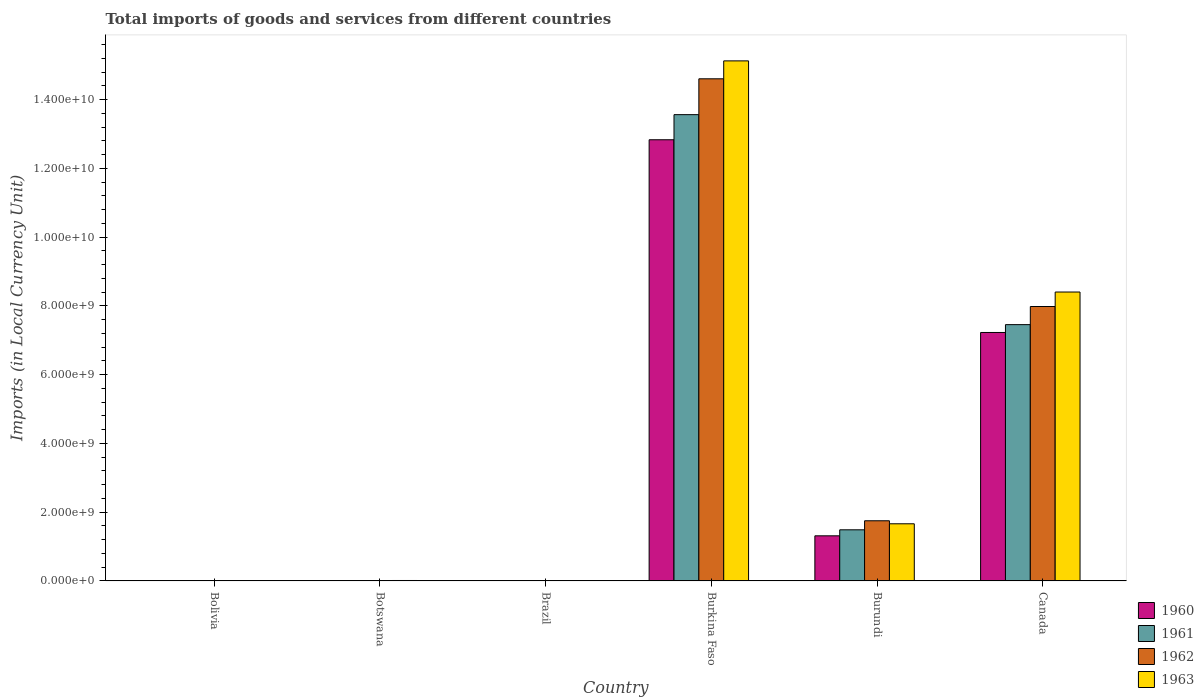How many different coloured bars are there?
Offer a terse response. 4. How many groups of bars are there?
Provide a short and direct response. 6. Are the number of bars on each tick of the X-axis equal?
Keep it short and to the point. Yes. How many bars are there on the 2nd tick from the left?
Offer a very short reply. 4. What is the label of the 6th group of bars from the left?
Provide a succinct answer. Canada. What is the Amount of goods and services imports in 1963 in Burkina Faso?
Make the answer very short. 1.51e+1. Across all countries, what is the maximum Amount of goods and services imports in 1962?
Offer a terse response. 1.46e+1. Across all countries, what is the minimum Amount of goods and services imports in 1960?
Your response must be concise. 7.33493e-5. In which country was the Amount of goods and services imports in 1962 maximum?
Provide a short and direct response. Burkina Faso. In which country was the Amount of goods and services imports in 1961 minimum?
Your answer should be compact. Brazil. What is the total Amount of goods and services imports in 1962 in the graph?
Your response must be concise. 2.44e+1. What is the difference between the Amount of goods and services imports in 1963 in Bolivia and that in Burkina Faso?
Ensure brevity in your answer.  -1.51e+1. What is the difference between the Amount of goods and services imports in 1963 in Burundi and the Amount of goods and services imports in 1960 in Brazil?
Your answer should be very brief. 1.66e+09. What is the average Amount of goods and services imports in 1960 per country?
Make the answer very short. 3.56e+09. What is the difference between the Amount of goods and services imports of/in 1960 and Amount of goods and services imports of/in 1962 in Burkina Faso?
Make the answer very short. -1.77e+09. What is the ratio of the Amount of goods and services imports in 1963 in Bolivia to that in Canada?
Your answer should be compact. 2.141785352670755e-7. Is the Amount of goods and services imports in 1963 in Bolivia less than that in Brazil?
Offer a very short reply. No. What is the difference between the highest and the second highest Amount of goods and services imports in 1961?
Provide a succinct answer. 6.11e+09. What is the difference between the highest and the lowest Amount of goods and services imports in 1963?
Your answer should be very brief. 1.51e+1. Is it the case that in every country, the sum of the Amount of goods and services imports in 1961 and Amount of goods and services imports in 1963 is greater than the sum of Amount of goods and services imports in 1962 and Amount of goods and services imports in 1960?
Provide a short and direct response. No. What does the 1st bar from the left in Burundi represents?
Keep it short and to the point. 1960. Is it the case that in every country, the sum of the Amount of goods and services imports in 1961 and Amount of goods and services imports in 1962 is greater than the Amount of goods and services imports in 1963?
Ensure brevity in your answer.  No. Are all the bars in the graph horizontal?
Give a very brief answer. No. What is the difference between two consecutive major ticks on the Y-axis?
Provide a succinct answer. 2.00e+09. Are the values on the major ticks of Y-axis written in scientific E-notation?
Keep it short and to the point. Yes. Does the graph contain grids?
Offer a terse response. No. Where does the legend appear in the graph?
Your response must be concise. Bottom right. How are the legend labels stacked?
Offer a terse response. Vertical. What is the title of the graph?
Offer a terse response. Total imports of goods and services from different countries. What is the label or title of the Y-axis?
Provide a short and direct response. Imports (in Local Currency Unit). What is the Imports (in Local Currency Unit) in 1960 in Bolivia?
Your answer should be very brief. 1300. What is the Imports (in Local Currency Unit) in 1961 in Bolivia?
Make the answer very short. 1300. What is the Imports (in Local Currency Unit) in 1962 in Bolivia?
Your response must be concise. 1600. What is the Imports (in Local Currency Unit) of 1963 in Bolivia?
Offer a very short reply. 1800. What is the Imports (in Local Currency Unit) of 1960 in Botswana?
Keep it short and to the point. 8.60e+06. What is the Imports (in Local Currency Unit) of 1961 in Botswana?
Your answer should be compact. 1.00e+07. What is the Imports (in Local Currency Unit) in 1962 in Botswana?
Keep it short and to the point. 1.14e+07. What is the Imports (in Local Currency Unit) of 1963 in Botswana?
Make the answer very short. 1.29e+07. What is the Imports (in Local Currency Unit) in 1960 in Brazil?
Your answer should be very brief. 7.33493e-5. What is the Imports (in Local Currency Unit) in 1961 in Brazil?
Provide a short and direct response. 0. What is the Imports (in Local Currency Unit) of 1962 in Brazil?
Your response must be concise. 0. What is the Imports (in Local Currency Unit) in 1963 in Brazil?
Offer a terse response. 0. What is the Imports (in Local Currency Unit) of 1960 in Burkina Faso?
Provide a short and direct response. 1.28e+1. What is the Imports (in Local Currency Unit) in 1961 in Burkina Faso?
Ensure brevity in your answer.  1.36e+1. What is the Imports (in Local Currency Unit) in 1962 in Burkina Faso?
Ensure brevity in your answer.  1.46e+1. What is the Imports (in Local Currency Unit) in 1963 in Burkina Faso?
Keep it short and to the point. 1.51e+1. What is the Imports (in Local Currency Unit) in 1960 in Burundi?
Give a very brief answer. 1.31e+09. What is the Imports (in Local Currency Unit) in 1961 in Burundi?
Ensure brevity in your answer.  1.49e+09. What is the Imports (in Local Currency Unit) in 1962 in Burundi?
Ensure brevity in your answer.  1.75e+09. What is the Imports (in Local Currency Unit) of 1963 in Burundi?
Give a very brief answer. 1.66e+09. What is the Imports (in Local Currency Unit) of 1960 in Canada?
Provide a short and direct response. 7.23e+09. What is the Imports (in Local Currency Unit) in 1961 in Canada?
Make the answer very short. 7.46e+09. What is the Imports (in Local Currency Unit) in 1962 in Canada?
Give a very brief answer. 7.98e+09. What is the Imports (in Local Currency Unit) in 1963 in Canada?
Your answer should be compact. 8.40e+09. Across all countries, what is the maximum Imports (in Local Currency Unit) of 1960?
Your answer should be very brief. 1.28e+1. Across all countries, what is the maximum Imports (in Local Currency Unit) in 1961?
Keep it short and to the point. 1.36e+1. Across all countries, what is the maximum Imports (in Local Currency Unit) of 1962?
Provide a short and direct response. 1.46e+1. Across all countries, what is the maximum Imports (in Local Currency Unit) of 1963?
Give a very brief answer. 1.51e+1. Across all countries, what is the minimum Imports (in Local Currency Unit) in 1960?
Keep it short and to the point. 7.33493e-5. Across all countries, what is the minimum Imports (in Local Currency Unit) of 1961?
Make the answer very short. 0. Across all countries, what is the minimum Imports (in Local Currency Unit) of 1962?
Give a very brief answer. 0. Across all countries, what is the minimum Imports (in Local Currency Unit) in 1963?
Your response must be concise. 0. What is the total Imports (in Local Currency Unit) of 1960 in the graph?
Provide a succinct answer. 2.14e+1. What is the total Imports (in Local Currency Unit) of 1961 in the graph?
Offer a very short reply. 2.25e+1. What is the total Imports (in Local Currency Unit) in 1962 in the graph?
Provide a succinct answer. 2.44e+1. What is the total Imports (in Local Currency Unit) in 1963 in the graph?
Your answer should be very brief. 2.52e+1. What is the difference between the Imports (in Local Currency Unit) of 1960 in Bolivia and that in Botswana?
Keep it short and to the point. -8.60e+06. What is the difference between the Imports (in Local Currency Unit) of 1961 in Bolivia and that in Botswana?
Ensure brevity in your answer.  -1.00e+07. What is the difference between the Imports (in Local Currency Unit) in 1962 in Bolivia and that in Botswana?
Offer a terse response. -1.14e+07. What is the difference between the Imports (in Local Currency Unit) of 1963 in Bolivia and that in Botswana?
Provide a succinct answer. -1.29e+07. What is the difference between the Imports (in Local Currency Unit) of 1960 in Bolivia and that in Brazil?
Ensure brevity in your answer.  1300. What is the difference between the Imports (in Local Currency Unit) of 1961 in Bolivia and that in Brazil?
Provide a short and direct response. 1300. What is the difference between the Imports (in Local Currency Unit) of 1962 in Bolivia and that in Brazil?
Provide a succinct answer. 1600. What is the difference between the Imports (in Local Currency Unit) of 1963 in Bolivia and that in Brazil?
Provide a short and direct response. 1800. What is the difference between the Imports (in Local Currency Unit) in 1960 in Bolivia and that in Burkina Faso?
Make the answer very short. -1.28e+1. What is the difference between the Imports (in Local Currency Unit) in 1961 in Bolivia and that in Burkina Faso?
Provide a succinct answer. -1.36e+1. What is the difference between the Imports (in Local Currency Unit) of 1962 in Bolivia and that in Burkina Faso?
Your answer should be very brief. -1.46e+1. What is the difference between the Imports (in Local Currency Unit) of 1963 in Bolivia and that in Burkina Faso?
Provide a succinct answer. -1.51e+1. What is the difference between the Imports (in Local Currency Unit) in 1960 in Bolivia and that in Burundi?
Keep it short and to the point. -1.31e+09. What is the difference between the Imports (in Local Currency Unit) of 1961 in Bolivia and that in Burundi?
Your answer should be compact. -1.49e+09. What is the difference between the Imports (in Local Currency Unit) of 1962 in Bolivia and that in Burundi?
Your answer should be very brief. -1.75e+09. What is the difference between the Imports (in Local Currency Unit) in 1963 in Bolivia and that in Burundi?
Your answer should be compact. -1.66e+09. What is the difference between the Imports (in Local Currency Unit) in 1960 in Bolivia and that in Canada?
Keep it short and to the point. -7.23e+09. What is the difference between the Imports (in Local Currency Unit) of 1961 in Bolivia and that in Canada?
Give a very brief answer. -7.46e+09. What is the difference between the Imports (in Local Currency Unit) in 1962 in Bolivia and that in Canada?
Offer a terse response. -7.98e+09. What is the difference between the Imports (in Local Currency Unit) of 1963 in Bolivia and that in Canada?
Offer a terse response. -8.40e+09. What is the difference between the Imports (in Local Currency Unit) in 1960 in Botswana and that in Brazil?
Give a very brief answer. 8.60e+06. What is the difference between the Imports (in Local Currency Unit) in 1961 in Botswana and that in Brazil?
Keep it short and to the point. 1.00e+07. What is the difference between the Imports (in Local Currency Unit) of 1962 in Botswana and that in Brazil?
Make the answer very short. 1.14e+07. What is the difference between the Imports (in Local Currency Unit) of 1963 in Botswana and that in Brazil?
Give a very brief answer. 1.29e+07. What is the difference between the Imports (in Local Currency Unit) of 1960 in Botswana and that in Burkina Faso?
Give a very brief answer. -1.28e+1. What is the difference between the Imports (in Local Currency Unit) of 1961 in Botswana and that in Burkina Faso?
Your answer should be compact. -1.36e+1. What is the difference between the Imports (in Local Currency Unit) of 1962 in Botswana and that in Burkina Faso?
Your response must be concise. -1.46e+1. What is the difference between the Imports (in Local Currency Unit) of 1963 in Botswana and that in Burkina Faso?
Offer a terse response. -1.51e+1. What is the difference between the Imports (in Local Currency Unit) of 1960 in Botswana and that in Burundi?
Give a very brief answer. -1.30e+09. What is the difference between the Imports (in Local Currency Unit) of 1961 in Botswana and that in Burundi?
Provide a succinct answer. -1.48e+09. What is the difference between the Imports (in Local Currency Unit) in 1962 in Botswana and that in Burundi?
Ensure brevity in your answer.  -1.74e+09. What is the difference between the Imports (in Local Currency Unit) of 1963 in Botswana and that in Burundi?
Make the answer very short. -1.65e+09. What is the difference between the Imports (in Local Currency Unit) in 1960 in Botswana and that in Canada?
Provide a succinct answer. -7.22e+09. What is the difference between the Imports (in Local Currency Unit) of 1961 in Botswana and that in Canada?
Your answer should be very brief. -7.45e+09. What is the difference between the Imports (in Local Currency Unit) in 1962 in Botswana and that in Canada?
Ensure brevity in your answer.  -7.97e+09. What is the difference between the Imports (in Local Currency Unit) in 1963 in Botswana and that in Canada?
Your response must be concise. -8.39e+09. What is the difference between the Imports (in Local Currency Unit) in 1960 in Brazil and that in Burkina Faso?
Your answer should be compact. -1.28e+1. What is the difference between the Imports (in Local Currency Unit) in 1961 in Brazil and that in Burkina Faso?
Provide a short and direct response. -1.36e+1. What is the difference between the Imports (in Local Currency Unit) in 1962 in Brazil and that in Burkina Faso?
Your response must be concise. -1.46e+1. What is the difference between the Imports (in Local Currency Unit) of 1963 in Brazil and that in Burkina Faso?
Ensure brevity in your answer.  -1.51e+1. What is the difference between the Imports (in Local Currency Unit) of 1960 in Brazil and that in Burundi?
Your response must be concise. -1.31e+09. What is the difference between the Imports (in Local Currency Unit) of 1961 in Brazil and that in Burundi?
Your answer should be compact. -1.49e+09. What is the difference between the Imports (in Local Currency Unit) in 1962 in Brazil and that in Burundi?
Give a very brief answer. -1.75e+09. What is the difference between the Imports (in Local Currency Unit) in 1963 in Brazil and that in Burundi?
Provide a succinct answer. -1.66e+09. What is the difference between the Imports (in Local Currency Unit) of 1960 in Brazil and that in Canada?
Your answer should be very brief. -7.23e+09. What is the difference between the Imports (in Local Currency Unit) of 1961 in Brazil and that in Canada?
Ensure brevity in your answer.  -7.46e+09. What is the difference between the Imports (in Local Currency Unit) in 1962 in Brazil and that in Canada?
Make the answer very short. -7.98e+09. What is the difference between the Imports (in Local Currency Unit) of 1963 in Brazil and that in Canada?
Provide a short and direct response. -8.40e+09. What is the difference between the Imports (in Local Currency Unit) in 1960 in Burkina Faso and that in Burundi?
Your answer should be compact. 1.15e+1. What is the difference between the Imports (in Local Currency Unit) in 1961 in Burkina Faso and that in Burundi?
Your answer should be compact. 1.21e+1. What is the difference between the Imports (in Local Currency Unit) of 1962 in Burkina Faso and that in Burundi?
Offer a very short reply. 1.29e+1. What is the difference between the Imports (in Local Currency Unit) in 1963 in Burkina Faso and that in Burundi?
Your response must be concise. 1.35e+1. What is the difference between the Imports (in Local Currency Unit) of 1960 in Burkina Faso and that in Canada?
Keep it short and to the point. 5.61e+09. What is the difference between the Imports (in Local Currency Unit) in 1961 in Burkina Faso and that in Canada?
Your response must be concise. 6.11e+09. What is the difference between the Imports (in Local Currency Unit) of 1962 in Burkina Faso and that in Canada?
Keep it short and to the point. 6.62e+09. What is the difference between the Imports (in Local Currency Unit) of 1963 in Burkina Faso and that in Canada?
Make the answer very short. 6.72e+09. What is the difference between the Imports (in Local Currency Unit) in 1960 in Burundi and that in Canada?
Offer a terse response. -5.91e+09. What is the difference between the Imports (in Local Currency Unit) of 1961 in Burundi and that in Canada?
Make the answer very short. -5.97e+09. What is the difference between the Imports (in Local Currency Unit) of 1962 in Burundi and that in Canada?
Keep it short and to the point. -6.23e+09. What is the difference between the Imports (in Local Currency Unit) in 1963 in Burundi and that in Canada?
Offer a terse response. -6.74e+09. What is the difference between the Imports (in Local Currency Unit) of 1960 in Bolivia and the Imports (in Local Currency Unit) of 1961 in Botswana?
Offer a very short reply. -1.00e+07. What is the difference between the Imports (in Local Currency Unit) in 1960 in Bolivia and the Imports (in Local Currency Unit) in 1962 in Botswana?
Give a very brief answer. -1.14e+07. What is the difference between the Imports (in Local Currency Unit) of 1960 in Bolivia and the Imports (in Local Currency Unit) of 1963 in Botswana?
Offer a very short reply. -1.29e+07. What is the difference between the Imports (in Local Currency Unit) of 1961 in Bolivia and the Imports (in Local Currency Unit) of 1962 in Botswana?
Your answer should be compact. -1.14e+07. What is the difference between the Imports (in Local Currency Unit) in 1961 in Bolivia and the Imports (in Local Currency Unit) in 1963 in Botswana?
Offer a very short reply. -1.29e+07. What is the difference between the Imports (in Local Currency Unit) of 1962 in Bolivia and the Imports (in Local Currency Unit) of 1963 in Botswana?
Provide a short and direct response. -1.29e+07. What is the difference between the Imports (in Local Currency Unit) in 1960 in Bolivia and the Imports (in Local Currency Unit) in 1961 in Brazil?
Offer a terse response. 1300. What is the difference between the Imports (in Local Currency Unit) in 1960 in Bolivia and the Imports (in Local Currency Unit) in 1962 in Brazil?
Give a very brief answer. 1300. What is the difference between the Imports (in Local Currency Unit) of 1960 in Bolivia and the Imports (in Local Currency Unit) of 1963 in Brazil?
Provide a succinct answer. 1300. What is the difference between the Imports (in Local Currency Unit) of 1961 in Bolivia and the Imports (in Local Currency Unit) of 1962 in Brazil?
Give a very brief answer. 1300. What is the difference between the Imports (in Local Currency Unit) of 1961 in Bolivia and the Imports (in Local Currency Unit) of 1963 in Brazil?
Offer a terse response. 1300. What is the difference between the Imports (in Local Currency Unit) of 1962 in Bolivia and the Imports (in Local Currency Unit) of 1963 in Brazil?
Your answer should be very brief. 1600. What is the difference between the Imports (in Local Currency Unit) of 1960 in Bolivia and the Imports (in Local Currency Unit) of 1961 in Burkina Faso?
Keep it short and to the point. -1.36e+1. What is the difference between the Imports (in Local Currency Unit) in 1960 in Bolivia and the Imports (in Local Currency Unit) in 1962 in Burkina Faso?
Your answer should be compact. -1.46e+1. What is the difference between the Imports (in Local Currency Unit) of 1960 in Bolivia and the Imports (in Local Currency Unit) of 1963 in Burkina Faso?
Offer a terse response. -1.51e+1. What is the difference between the Imports (in Local Currency Unit) of 1961 in Bolivia and the Imports (in Local Currency Unit) of 1962 in Burkina Faso?
Your answer should be very brief. -1.46e+1. What is the difference between the Imports (in Local Currency Unit) of 1961 in Bolivia and the Imports (in Local Currency Unit) of 1963 in Burkina Faso?
Make the answer very short. -1.51e+1. What is the difference between the Imports (in Local Currency Unit) in 1962 in Bolivia and the Imports (in Local Currency Unit) in 1963 in Burkina Faso?
Ensure brevity in your answer.  -1.51e+1. What is the difference between the Imports (in Local Currency Unit) of 1960 in Bolivia and the Imports (in Local Currency Unit) of 1961 in Burundi?
Ensure brevity in your answer.  -1.49e+09. What is the difference between the Imports (in Local Currency Unit) in 1960 in Bolivia and the Imports (in Local Currency Unit) in 1962 in Burundi?
Your answer should be compact. -1.75e+09. What is the difference between the Imports (in Local Currency Unit) in 1960 in Bolivia and the Imports (in Local Currency Unit) in 1963 in Burundi?
Your answer should be compact. -1.66e+09. What is the difference between the Imports (in Local Currency Unit) of 1961 in Bolivia and the Imports (in Local Currency Unit) of 1962 in Burundi?
Ensure brevity in your answer.  -1.75e+09. What is the difference between the Imports (in Local Currency Unit) in 1961 in Bolivia and the Imports (in Local Currency Unit) in 1963 in Burundi?
Give a very brief answer. -1.66e+09. What is the difference between the Imports (in Local Currency Unit) of 1962 in Bolivia and the Imports (in Local Currency Unit) of 1963 in Burundi?
Provide a short and direct response. -1.66e+09. What is the difference between the Imports (in Local Currency Unit) of 1960 in Bolivia and the Imports (in Local Currency Unit) of 1961 in Canada?
Keep it short and to the point. -7.46e+09. What is the difference between the Imports (in Local Currency Unit) of 1960 in Bolivia and the Imports (in Local Currency Unit) of 1962 in Canada?
Ensure brevity in your answer.  -7.98e+09. What is the difference between the Imports (in Local Currency Unit) in 1960 in Bolivia and the Imports (in Local Currency Unit) in 1963 in Canada?
Your answer should be compact. -8.40e+09. What is the difference between the Imports (in Local Currency Unit) of 1961 in Bolivia and the Imports (in Local Currency Unit) of 1962 in Canada?
Provide a short and direct response. -7.98e+09. What is the difference between the Imports (in Local Currency Unit) in 1961 in Bolivia and the Imports (in Local Currency Unit) in 1963 in Canada?
Your answer should be very brief. -8.40e+09. What is the difference between the Imports (in Local Currency Unit) of 1962 in Bolivia and the Imports (in Local Currency Unit) of 1963 in Canada?
Offer a terse response. -8.40e+09. What is the difference between the Imports (in Local Currency Unit) in 1960 in Botswana and the Imports (in Local Currency Unit) in 1961 in Brazil?
Make the answer very short. 8.60e+06. What is the difference between the Imports (in Local Currency Unit) of 1960 in Botswana and the Imports (in Local Currency Unit) of 1962 in Brazil?
Offer a very short reply. 8.60e+06. What is the difference between the Imports (in Local Currency Unit) of 1960 in Botswana and the Imports (in Local Currency Unit) of 1963 in Brazil?
Keep it short and to the point. 8.60e+06. What is the difference between the Imports (in Local Currency Unit) of 1961 in Botswana and the Imports (in Local Currency Unit) of 1962 in Brazil?
Offer a terse response. 1.00e+07. What is the difference between the Imports (in Local Currency Unit) in 1961 in Botswana and the Imports (in Local Currency Unit) in 1963 in Brazil?
Make the answer very short. 1.00e+07. What is the difference between the Imports (in Local Currency Unit) of 1962 in Botswana and the Imports (in Local Currency Unit) of 1963 in Brazil?
Ensure brevity in your answer.  1.14e+07. What is the difference between the Imports (in Local Currency Unit) of 1960 in Botswana and the Imports (in Local Currency Unit) of 1961 in Burkina Faso?
Provide a succinct answer. -1.36e+1. What is the difference between the Imports (in Local Currency Unit) in 1960 in Botswana and the Imports (in Local Currency Unit) in 1962 in Burkina Faso?
Your answer should be compact. -1.46e+1. What is the difference between the Imports (in Local Currency Unit) in 1960 in Botswana and the Imports (in Local Currency Unit) in 1963 in Burkina Faso?
Offer a terse response. -1.51e+1. What is the difference between the Imports (in Local Currency Unit) in 1961 in Botswana and the Imports (in Local Currency Unit) in 1962 in Burkina Faso?
Your answer should be compact. -1.46e+1. What is the difference between the Imports (in Local Currency Unit) in 1961 in Botswana and the Imports (in Local Currency Unit) in 1963 in Burkina Faso?
Give a very brief answer. -1.51e+1. What is the difference between the Imports (in Local Currency Unit) of 1962 in Botswana and the Imports (in Local Currency Unit) of 1963 in Burkina Faso?
Offer a very short reply. -1.51e+1. What is the difference between the Imports (in Local Currency Unit) in 1960 in Botswana and the Imports (in Local Currency Unit) in 1961 in Burundi?
Offer a very short reply. -1.48e+09. What is the difference between the Imports (in Local Currency Unit) of 1960 in Botswana and the Imports (in Local Currency Unit) of 1962 in Burundi?
Offer a very short reply. -1.74e+09. What is the difference between the Imports (in Local Currency Unit) in 1960 in Botswana and the Imports (in Local Currency Unit) in 1963 in Burundi?
Provide a succinct answer. -1.65e+09. What is the difference between the Imports (in Local Currency Unit) in 1961 in Botswana and the Imports (in Local Currency Unit) in 1962 in Burundi?
Offer a terse response. -1.74e+09. What is the difference between the Imports (in Local Currency Unit) of 1961 in Botswana and the Imports (in Local Currency Unit) of 1963 in Burundi?
Keep it short and to the point. -1.65e+09. What is the difference between the Imports (in Local Currency Unit) in 1962 in Botswana and the Imports (in Local Currency Unit) in 1963 in Burundi?
Provide a short and direct response. -1.65e+09. What is the difference between the Imports (in Local Currency Unit) of 1960 in Botswana and the Imports (in Local Currency Unit) of 1961 in Canada?
Keep it short and to the point. -7.45e+09. What is the difference between the Imports (in Local Currency Unit) of 1960 in Botswana and the Imports (in Local Currency Unit) of 1962 in Canada?
Your answer should be very brief. -7.97e+09. What is the difference between the Imports (in Local Currency Unit) in 1960 in Botswana and the Imports (in Local Currency Unit) in 1963 in Canada?
Offer a very short reply. -8.40e+09. What is the difference between the Imports (in Local Currency Unit) in 1961 in Botswana and the Imports (in Local Currency Unit) in 1962 in Canada?
Ensure brevity in your answer.  -7.97e+09. What is the difference between the Imports (in Local Currency Unit) in 1961 in Botswana and the Imports (in Local Currency Unit) in 1963 in Canada?
Offer a terse response. -8.39e+09. What is the difference between the Imports (in Local Currency Unit) of 1962 in Botswana and the Imports (in Local Currency Unit) of 1963 in Canada?
Your response must be concise. -8.39e+09. What is the difference between the Imports (in Local Currency Unit) of 1960 in Brazil and the Imports (in Local Currency Unit) of 1961 in Burkina Faso?
Your response must be concise. -1.36e+1. What is the difference between the Imports (in Local Currency Unit) of 1960 in Brazil and the Imports (in Local Currency Unit) of 1962 in Burkina Faso?
Offer a terse response. -1.46e+1. What is the difference between the Imports (in Local Currency Unit) of 1960 in Brazil and the Imports (in Local Currency Unit) of 1963 in Burkina Faso?
Your answer should be compact. -1.51e+1. What is the difference between the Imports (in Local Currency Unit) in 1961 in Brazil and the Imports (in Local Currency Unit) in 1962 in Burkina Faso?
Provide a succinct answer. -1.46e+1. What is the difference between the Imports (in Local Currency Unit) of 1961 in Brazil and the Imports (in Local Currency Unit) of 1963 in Burkina Faso?
Your response must be concise. -1.51e+1. What is the difference between the Imports (in Local Currency Unit) in 1962 in Brazil and the Imports (in Local Currency Unit) in 1963 in Burkina Faso?
Offer a terse response. -1.51e+1. What is the difference between the Imports (in Local Currency Unit) of 1960 in Brazil and the Imports (in Local Currency Unit) of 1961 in Burundi?
Your answer should be very brief. -1.49e+09. What is the difference between the Imports (in Local Currency Unit) in 1960 in Brazil and the Imports (in Local Currency Unit) in 1962 in Burundi?
Make the answer very short. -1.75e+09. What is the difference between the Imports (in Local Currency Unit) of 1960 in Brazil and the Imports (in Local Currency Unit) of 1963 in Burundi?
Make the answer very short. -1.66e+09. What is the difference between the Imports (in Local Currency Unit) in 1961 in Brazil and the Imports (in Local Currency Unit) in 1962 in Burundi?
Give a very brief answer. -1.75e+09. What is the difference between the Imports (in Local Currency Unit) of 1961 in Brazil and the Imports (in Local Currency Unit) of 1963 in Burundi?
Your answer should be very brief. -1.66e+09. What is the difference between the Imports (in Local Currency Unit) of 1962 in Brazil and the Imports (in Local Currency Unit) of 1963 in Burundi?
Make the answer very short. -1.66e+09. What is the difference between the Imports (in Local Currency Unit) of 1960 in Brazil and the Imports (in Local Currency Unit) of 1961 in Canada?
Your response must be concise. -7.46e+09. What is the difference between the Imports (in Local Currency Unit) of 1960 in Brazil and the Imports (in Local Currency Unit) of 1962 in Canada?
Provide a short and direct response. -7.98e+09. What is the difference between the Imports (in Local Currency Unit) in 1960 in Brazil and the Imports (in Local Currency Unit) in 1963 in Canada?
Your answer should be compact. -8.40e+09. What is the difference between the Imports (in Local Currency Unit) in 1961 in Brazil and the Imports (in Local Currency Unit) in 1962 in Canada?
Your response must be concise. -7.98e+09. What is the difference between the Imports (in Local Currency Unit) of 1961 in Brazil and the Imports (in Local Currency Unit) of 1963 in Canada?
Offer a very short reply. -8.40e+09. What is the difference between the Imports (in Local Currency Unit) in 1962 in Brazil and the Imports (in Local Currency Unit) in 1963 in Canada?
Give a very brief answer. -8.40e+09. What is the difference between the Imports (in Local Currency Unit) of 1960 in Burkina Faso and the Imports (in Local Currency Unit) of 1961 in Burundi?
Your response must be concise. 1.13e+1. What is the difference between the Imports (in Local Currency Unit) in 1960 in Burkina Faso and the Imports (in Local Currency Unit) in 1962 in Burundi?
Provide a short and direct response. 1.11e+1. What is the difference between the Imports (in Local Currency Unit) of 1960 in Burkina Faso and the Imports (in Local Currency Unit) of 1963 in Burundi?
Your answer should be very brief. 1.12e+1. What is the difference between the Imports (in Local Currency Unit) in 1961 in Burkina Faso and the Imports (in Local Currency Unit) in 1962 in Burundi?
Offer a terse response. 1.18e+1. What is the difference between the Imports (in Local Currency Unit) of 1961 in Burkina Faso and the Imports (in Local Currency Unit) of 1963 in Burundi?
Keep it short and to the point. 1.19e+1. What is the difference between the Imports (in Local Currency Unit) in 1962 in Burkina Faso and the Imports (in Local Currency Unit) in 1963 in Burundi?
Offer a very short reply. 1.29e+1. What is the difference between the Imports (in Local Currency Unit) in 1960 in Burkina Faso and the Imports (in Local Currency Unit) in 1961 in Canada?
Provide a short and direct response. 5.38e+09. What is the difference between the Imports (in Local Currency Unit) in 1960 in Burkina Faso and the Imports (in Local Currency Unit) in 1962 in Canada?
Ensure brevity in your answer.  4.85e+09. What is the difference between the Imports (in Local Currency Unit) in 1960 in Burkina Faso and the Imports (in Local Currency Unit) in 1963 in Canada?
Your answer should be compact. 4.43e+09. What is the difference between the Imports (in Local Currency Unit) of 1961 in Burkina Faso and the Imports (in Local Currency Unit) of 1962 in Canada?
Give a very brief answer. 5.58e+09. What is the difference between the Imports (in Local Currency Unit) of 1961 in Burkina Faso and the Imports (in Local Currency Unit) of 1963 in Canada?
Provide a succinct answer. 5.16e+09. What is the difference between the Imports (in Local Currency Unit) of 1962 in Burkina Faso and the Imports (in Local Currency Unit) of 1963 in Canada?
Ensure brevity in your answer.  6.20e+09. What is the difference between the Imports (in Local Currency Unit) of 1960 in Burundi and the Imports (in Local Currency Unit) of 1961 in Canada?
Provide a succinct answer. -6.14e+09. What is the difference between the Imports (in Local Currency Unit) in 1960 in Burundi and the Imports (in Local Currency Unit) in 1962 in Canada?
Offer a very short reply. -6.67e+09. What is the difference between the Imports (in Local Currency Unit) in 1960 in Burundi and the Imports (in Local Currency Unit) in 1963 in Canada?
Your answer should be very brief. -7.09e+09. What is the difference between the Imports (in Local Currency Unit) in 1961 in Burundi and the Imports (in Local Currency Unit) in 1962 in Canada?
Offer a terse response. -6.50e+09. What is the difference between the Imports (in Local Currency Unit) in 1961 in Burundi and the Imports (in Local Currency Unit) in 1963 in Canada?
Ensure brevity in your answer.  -6.92e+09. What is the difference between the Imports (in Local Currency Unit) of 1962 in Burundi and the Imports (in Local Currency Unit) of 1963 in Canada?
Offer a very short reply. -6.65e+09. What is the average Imports (in Local Currency Unit) of 1960 per country?
Your response must be concise. 3.56e+09. What is the average Imports (in Local Currency Unit) in 1961 per country?
Your response must be concise. 3.75e+09. What is the average Imports (in Local Currency Unit) of 1962 per country?
Your response must be concise. 4.06e+09. What is the average Imports (in Local Currency Unit) in 1963 per country?
Provide a short and direct response. 4.20e+09. What is the difference between the Imports (in Local Currency Unit) of 1960 and Imports (in Local Currency Unit) of 1962 in Bolivia?
Your answer should be compact. -300. What is the difference between the Imports (in Local Currency Unit) in 1960 and Imports (in Local Currency Unit) in 1963 in Bolivia?
Your answer should be compact. -500. What is the difference between the Imports (in Local Currency Unit) in 1961 and Imports (in Local Currency Unit) in 1962 in Bolivia?
Make the answer very short. -300. What is the difference between the Imports (in Local Currency Unit) in 1961 and Imports (in Local Currency Unit) in 1963 in Bolivia?
Keep it short and to the point. -500. What is the difference between the Imports (in Local Currency Unit) in 1962 and Imports (in Local Currency Unit) in 1963 in Bolivia?
Offer a very short reply. -200. What is the difference between the Imports (in Local Currency Unit) of 1960 and Imports (in Local Currency Unit) of 1961 in Botswana?
Ensure brevity in your answer.  -1.40e+06. What is the difference between the Imports (in Local Currency Unit) of 1960 and Imports (in Local Currency Unit) of 1962 in Botswana?
Provide a succinct answer. -2.80e+06. What is the difference between the Imports (in Local Currency Unit) of 1960 and Imports (in Local Currency Unit) of 1963 in Botswana?
Make the answer very short. -4.30e+06. What is the difference between the Imports (in Local Currency Unit) in 1961 and Imports (in Local Currency Unit) in 1962 in Botswana?
Your answer should be compact. -1.40e+06. What is the difference between the Imports (in Local Currency Unit) in 1961 and Imports (in Local Currency Unit) in 1963 in Botswana?
Keep it short and to the point. -2.90e+06. What is the difference between the Imports (in Local Currency Unit) in 1962 and Imports (in Local Currency Unit) in 1963 in Botswana?
Give a very brief answer. -1.50e+06. What is the difference between the Imports (in Local Currency Unit) of 1960 and Imports (in Local Currency Unit) of 1962 in Brazil?
Give a very brief answer. -0. What is the difference between the Imports (in Local Currency Unit) of 1960 and Imports (in Local Currency Unit) of 1963 in Brazil?
Offer a very short reply. -0. What is the difference between the Imports (in Local Currency Unit) in 1961 and Imports (in Local Currency Unit) in 1962 in Brazil?
Ensure brevity in your answer.  -0. What is the difference between the Imports (in Local Currency Unit) of 1961 and Imports (in Local Currency Unit) of 1963 in Brazil?
Ensure brevity in your answer.  -0. What is the difference between the Imports (in Local Currency Unit) in 1962 and Imports (in Local Currency Unit) in 1963 in Brazil?
Offer a very short reply. -0. What is the difference between the Imports (in Local Currency Unit) of 1960 and Imports (in Local Currency Unit) of 1961 in Burkina Faso?
Your response must be concise. -7.30e+08. What is the difference between the Imports (in Local Currency Unit) in 1960 and Imports (in Local Currency Unit) in 1962 in Burkina Faso?
Provide a short and direct response. -1.77e+09. What is the difference between the Imports (in Local Currency Unit) of 1960 and Imports (in Local Currency Unit) of 1963 in Burkina Faso?
Make the answer very short. -2.29e+09. What is the difference between the Imports (in Local Currency Unit) in 1961 and Imports (in Local Currency Unit) in 1962 in Burkina Faso?
Make the answer very short. -1.04e+09. What is the difference between the Imports (in Local Currency Unit) in 1961 and Imports (in Local Currency Unit) in 1963 in Burkina Faso?
Offer a terse response. -1.56e+09. What is the difference between the Imports (in Local Currency Unit) in 1962 and Imports (in Local Currency Unit) in 1963 in Burkina Faso?
Give a very brief answer. -5.21e+08. What is the difference between the Imports (in Local Currency Unit) of 1960 and Imports (in Local Currency Unit) of 1961 in Burundi?
Give a very brief answer. -1.75e+08. What is the difference between the Imports (in Local Currency Unit) in 1960 and Imports (in Local Currency Unit) in 1962 in Burundi?
Give a very brief answer. -4.38e+08. What is the difference between the Imports (in Local Currency Unit) of 1960 and Imports (in Local Currency Unit) of 1963 in Burundi?
Provide a succinct answer. -3.50e+08. What is the difference between the Imports (in Local Currency Unit) in 1961 and Imports (in Local Currency Unit) in 1962 in Burundi?
Your answer should be compact. -2.62e+08. What is the difference between the Imports (in Local Currency Unit) of 1961 and Imports (in Local Currency Unit) of 1963 in Burundi?
Offer a very short reply. -1.75e+08. What is the difference between the Imports (in Local Currency Unit) in 1962 and Imports (in Local Currency Unit) in 1963 in Burundi?
Keep it short and to the point. 8.75e+07. What is the difference between the Imports (in Local Currency Unit) in 1960 and Imports (in Local Currency Unit) in 1961 in Canada?
Provide a short and direct response. -2.28e+08. What is the difference between the Imports (in Local Currency Unit) in 1960 and Imports (in Local Currency Unit) in 1962 in Canada?
Make the answer very short. -7.56e+08. What is the difference between the Imports (in Local Currency Unit) of 1960 and Imports (in Local Currency Unit) of 1963 in Canada?
Give a very brief answer. -1.18e+09. What is the difference between the Imports (in Local Currency Unit) in 1961 and Imports (in Local Currency Unit) in 1962 in Canada?
Your answer should be very brief. -5.27e+08. What is the difference between the Imports (in Local Currency Unit) of 1961 and Imports (in Local Currency Unit) of 1963 in Canada?
Give a very brief answer. -9.49e+08. What is the difference between the Imports (in Local Currency Unit) of 1962 and Imports (in Local Currency Unit) of 1963 in Canada?
Keep it short and to the point. -4.21e+08. What is the ratio of the Imports (in Local Currency Unit) of 1960 in Bolivia to that in Botswana?
Provide a succinct answer. 0. What is the ratio of the Imports (in Local Currency Unit) in 1961 in Bolivia to that in Botswana?
Make the answer very short. 0. What is the ratio of the Imports (in Local Currency Unit) in 1963 in Bolivia to that in Botswana?
Offer a terse response. 0. What is the ratio of the Imports (in Local Currency Unit) in 1960 in Bolivia to that in Brazil?
Your answer should be very brief. 1.77e+07. What is the ratio of the Imports (in Local Currency Unit) in 1961 in Bolivia to that in Brazil?
Keep it short and to the point. 1.19e+07. What is the ratio of the Imports (in Local Currency Unit) in 1962 in Bolivia to that in Brazil?
Your answer should be very brief. 1.10e+07. What is the ratio of the Imports (in Local Currency Unit) in 1963 in Bolivia to that in Brazil?
Your response must be concise. 4.11e+06. What is the ratio of the Imports (in Local Currency Unit) in 1962 in Bolivia to that in Burkina Faso?
Provide a short and direct response. 0. What is the ratio of the Imports (in Local Currency Unit) of 1961 in Bolivia to that in Canada?
Offer a very short reply. 0. What is the ratio of the Imports (in Local Currency Unit) of 1960 in Botswana to that in Brazil?
Offer a terse response. 1.17e+11. What is the ratio of the Imports (in Local Currency Unit) of 1961 in Botswana to that in Brazil?
Provide a succinct answer. 9.13e+1. What is the ratio of the Imports (in Local Currency Unit) of 1962 in Botswana to that in Brazil?
Offer a terse response. 7.82e+1. What is the ratio of the Imports (in Local Currency Unit) in 1963 in Botswana to that in Brazil?
Give a very brief answer. 2.94e+1. What is the ratio of the Imports (in Local Currency Unit) in 1960 in Botswana to that in Burkina Faso?
Ensure brevity in your answer.  0. What is the ratio of the Imports (in Local Currency Unit) of 1961 in Botswana to that in Burkina Faso?
Your answer should be compact. 0. What is the ratio of the Imports (in Local Currency Unit) of 1962 in Botswana to that in Burkina Faso?
Your answer should be very brief. 0. What is the ratio of the Imports (in Local Currency Unit) of 1963 in Botswana to that in Burkina Faso?
Provide a short and direct response. 0. What is the ratio of the Imports (in Local Currency Unit) of 1960 in Botswana to that in Burundi?
Your answer should be very brief. 0.01. What is the ratio of the Imports (in Local Currency Unit) in 1961 in Botswana to that in Burundi?
Make the answer very short. 0.01. What is the ratio of the Imports (in Local Currency Unit) of 1962 in Botswana to that in Burundi?
Give a very brief answer. 0.01. What is the ratio of the Imports (in Local Currency Unit) of 1963 in Botswana to that in Burundi?
Your answer should be compact. 0.01. What is the ratio of the Imports (in Local Currency Unit) of 1960 in Botswana to that in Canada?
Give a very brief answer. 0. What is the ratio of the Imports (in Local Currency Unit) in 1961 in Botswana to that in Canada?
Your answer should be very brief. 0. What is the ratio of the Imports (in Local Currency Unit) in 1962 in Botswana to that in Canada?
Provide a short and direct response. 0. What is the ratio of the Imports (in Local Currency Unit) of 1963 in Botswana to that in Canada?
Offer a terse response. 0. What is the ratio of the Imports (in Local Currency Unit) in 1960 in Brazil to that in Burkina Faso?
Give a very brief answer. 0. What is the ratio of the Imports (in Local Currency Unit) in 1962 in Brazil to that in Burkina Faso?
Your response must be concise. 0. What is the ratio of the Imports (in Local Currency Unit) in 1963 in Brazil to that in Burundi?
Offer a very short reply. 0. What is the ratio of the Imports (in Local Currency Unit) of 1963 in Brazil to that in Canada?
Offer a terse response. 0. What is the ratio of the Imports (in Local Currency Unit) in 1960 in Burkina Faso to that in Burundi?
Ensure brevity in your answer.  9.78. What is the ratio of the Imports (in Local Currency Unit) of 1961 in Burkina Faso to that in Burundi?
Ensure brevity in your answer.  9.12. What is the ratio of the Imports (in Local Currency Unit) in 1962 in Burkina Faso to that in Burundi?
Your answer should be very brief. 8.35. What is the ratio of the Imports (in Local Currency Unit) in 1963 in Burkina Faso to that in Burundi?
Keep it short and to the point. 9.1. What is the ratio of the Imports (in Local Currency Unit) in 1960 in Burkina Faso to that in Canada?
Make the answer very short. 1.78. What is the ratio of the Imports (in Local Currency Unit) of 1961 in Burkina Faso to that in Canada?
Your answer should be compact. 1.82. What is the ratio of the Imports (in Local Currency Unit) in 1962 in Burkina Faso to that in Canada?
Offer a very short reply. 1.83. What is the ratio of the Imports (in Local Currency Unit) in 1960 in Burundi to that in Canada?
Ensure brevity in your answer.  0.18. What is the ratio of the Imports (in Local Currency Unit) in 1961 in Burundi to that in Canada?
Provide a short and direct response. 0.2. What is the ratio of the Imports (in Local Currency Unit) in 1962 in Burundi to that in Canada?
Your answer should be very brief. 0.22. What is the ratio of the Imports (in Local Currency Unit) of 1963 in Burundi to that in Canada?
Your answer should be very brief. 0.2. What is the difference between the highest and the second highest Imports (in Local Currency Unit) of 1960?
Offer a very short reply. 5.61e+09. What is the difference between the highest and the second highest Imports (in Local Currency Unit) of 1961?
Provide a short and direct response. 6.11e+09. What is the difference between the highest and the second highest Imports (in Local Currency Unit) in 1962?
Offer a terse response. 6.62e+09. What is the difference between the highest and the second highest Imports (in Local Currency Unit) of 1963?
Keep it short and to the point. 6.72e+09. What is the difference between the highest and the lowest Imports (in Local Currency Unit) of 1960?
Make the answer very short. 1.28e+1. What is the difference between the highest and the lowest Imports (in Local Currency Unit) of 1961?
Your response must be concise. 1.36e+1. What is the difference between the highest and the lowest Imports (in Local Currency Unit) of 1962?
Provide a short and direct response. 1.46e+1. What is the difference between the highest and the lowest Imports (in Local Currency Unit) in 1963?
Keep it short and to the point. 1.51e+1. 